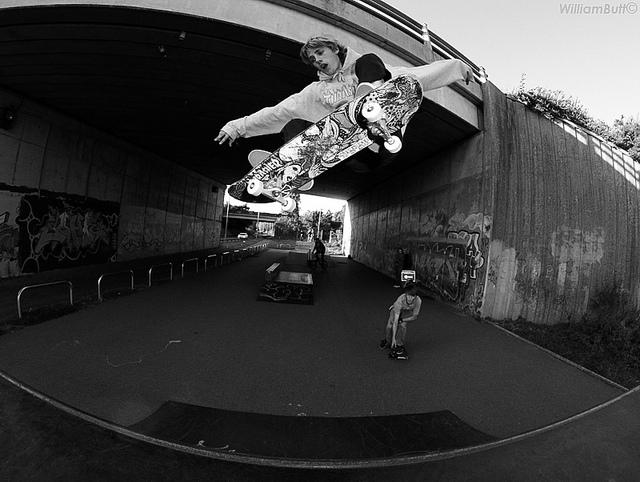Is the picture white and black?
Quick response, please. Yes. Can you see the bottom of the skateboard?
Give a very brief answer. Yes. Is this kid getting some serious air?
Keep it brief. Yes. 